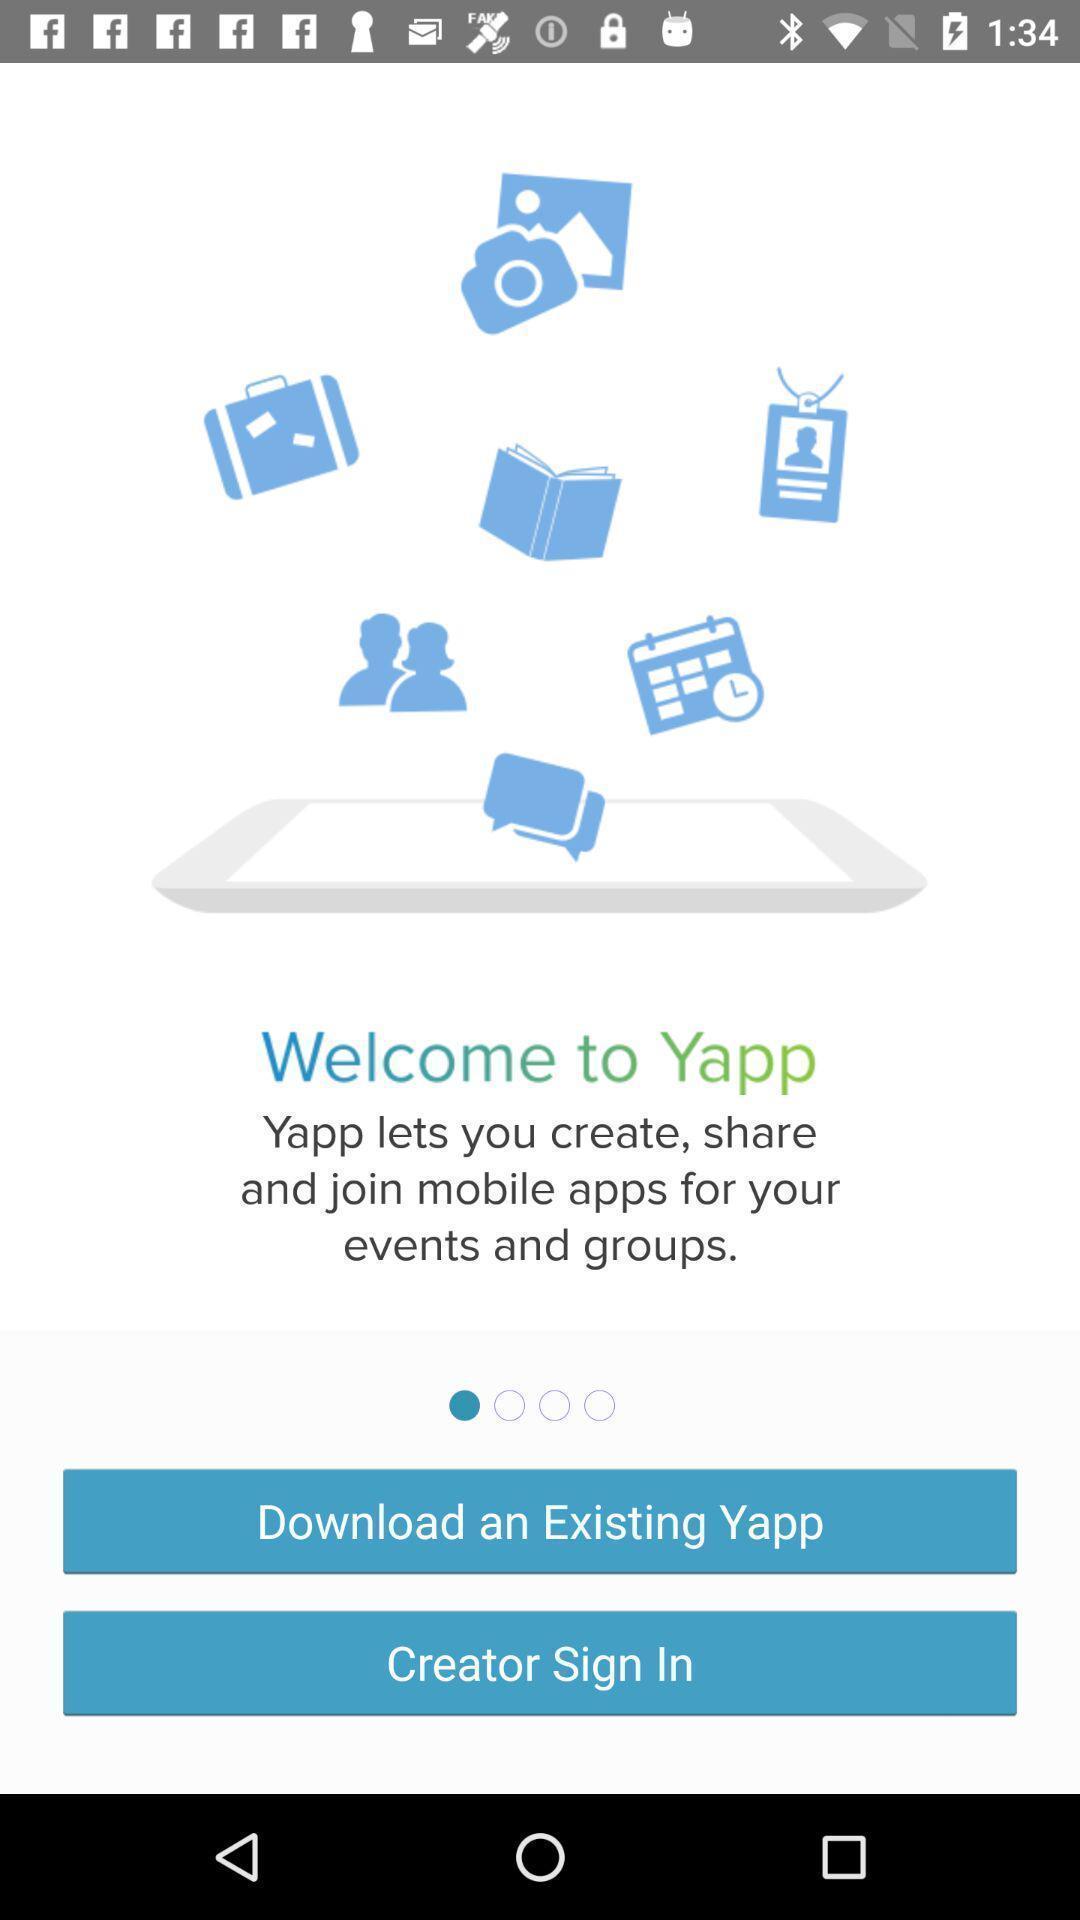Describe the key features of this screenshot. Welcome page. 